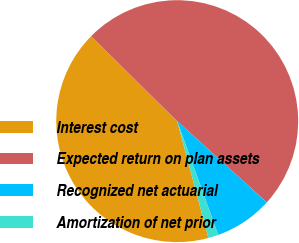<chart> <loc_0><loc_0><loc_500><loc_500><pie_chart><fcel>Interest cost<fcel>Expected return on plan assets<fcel>Recognized net actuarial<fcel>Amortization of net prior<nl><fcel>41.55%<fcel>49.32%<fcel>7.77%<fcel>1.35%<nl></chart> 